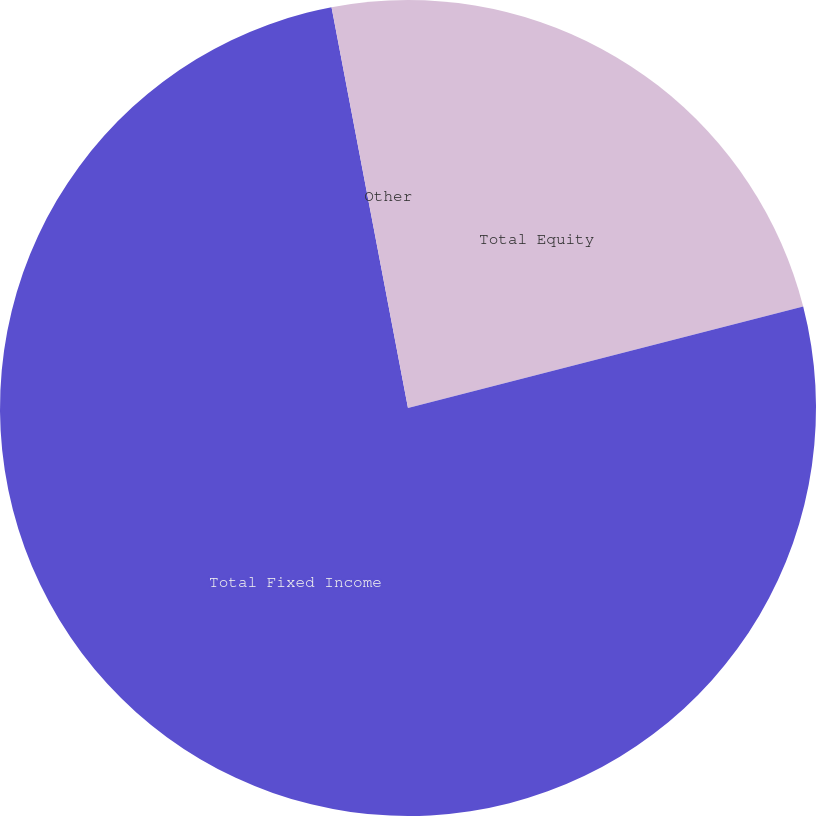Convert chart. <chart><loc_0><loc_0><loc_500><loc_500><pie_chart><fcel>Total Equity<fcel>Total Fixed Income<fcel>Other<nl><fcel>21.0%<fcel>76.0%<fcel>3.0%<nl></chart> 